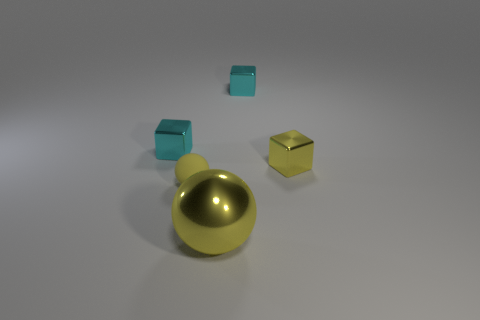Subtract all yellow metal cubes. How many cubes are left? 2 Subtract 1 blocks. How many blocks are left? 2 Subtract all cubes. How many objects are left? 2 Add 3 yellow rubber things. How many objects exist? 8 Subtract all cyan cubes. How many cubes are left? 1 Subtract 0 blue cylinders. How many objects are left? 5 Subtract all blue balls. Subtract all purple cubes. How many balls are left? 2 Subtract all red cubes. How many purple balls are left? 0 Subtract all yellow metal objects. Subtract all metallic spheres. How many objects are left? 2 Add 3 small cyan things. How many small cyan things are left? 5 